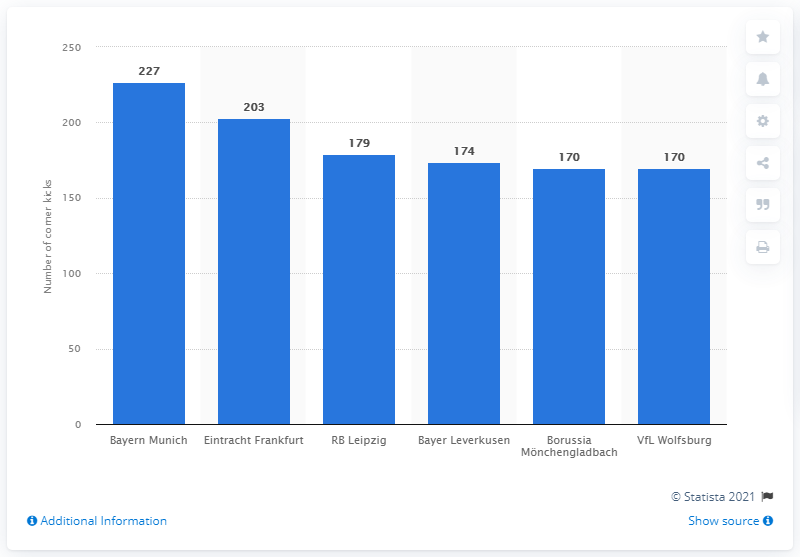Point out several critical features in this image. Bayern Munich executed the most corner kicks in Germany during the 2020/2021 season. 